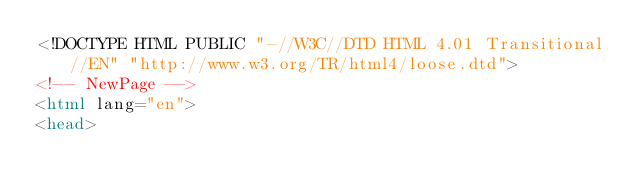<code> <loc_0><loc_0><loc_500><loc_500><_HTML_><!DOCTYPE HTML PUBLIC "-//W3C//DTD HTML 4.01 Transitional//EN" "http://www.w3.org/TR/html4/loose.dtd">
<!-- NewPage -->
<html lang="en">
<head></code> 